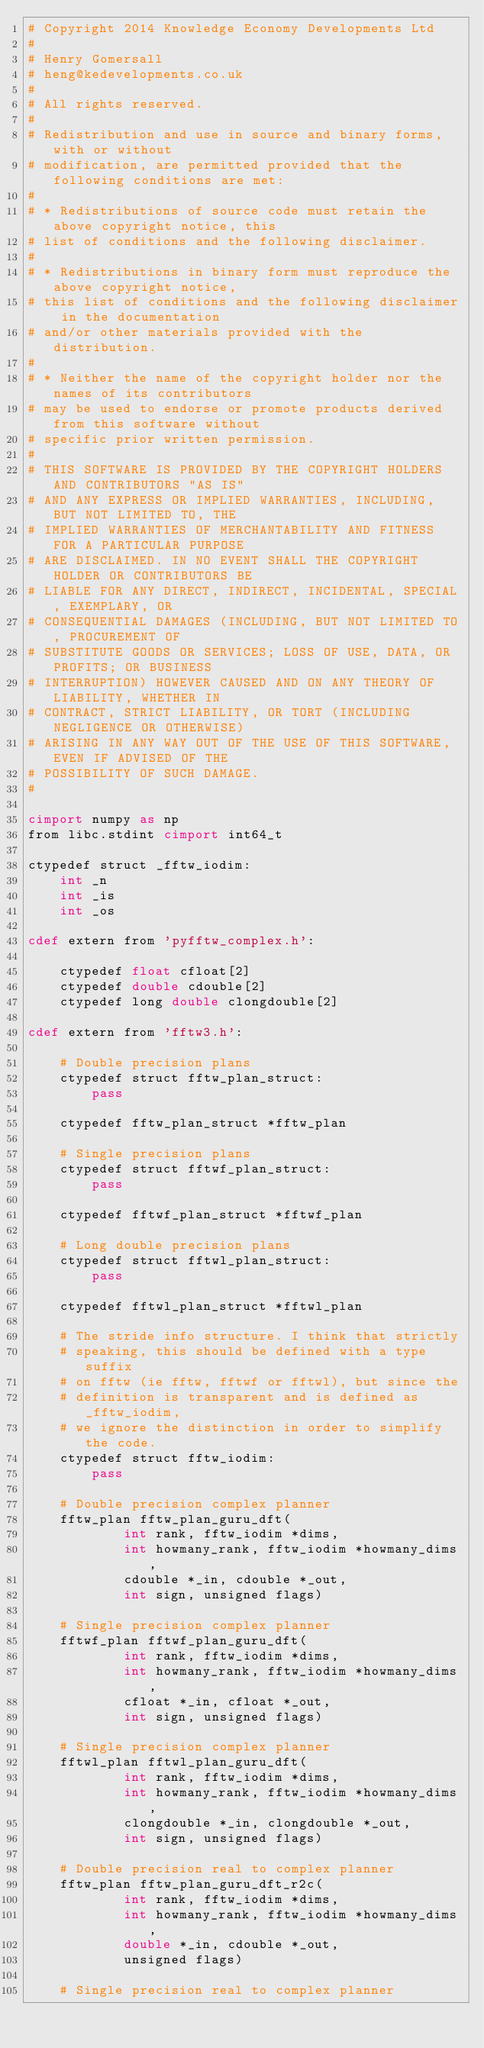Convert code to text. <code><loc_0><loc_0><loc_500><loc_500><_Cython_># Copyright 2014 Knowledge Economy Developments Ltd
# 
# Henry Gomersall
# heng@kedevelopments.co.uk
#
# All rights reserved.
#
# Redistribution and use in source and binary forms, with or without
# modification, are permitted provided that the following conditions are met:
#
# * Redistributions of source code must retain the above copyright notice, this
# list of conditions and the following disclaimer.
#
# * Redistributions in binary form must reproduce the above copyright notice,
# this list of conditions and the following disclaimer in the documentation
# and/or other materials provided with the distribution.
#
# * Neither the name of the copyright holder nor the names of its contributors
# may be used to endorse or promote products derived from this software without
# specific prior written permission.
#
# THIS SOFTWARE IS PROVIDED BY THE COPYRIGHT HOLDERS AND CONTRIBUTORS "AS IS"
# AND ANY EXPRESS OR IMPLIED WARRANTIES, INCLUDING, BUT NOT LIMITED TO, THE
# IMPLIED WARRANTIES OF MERCHANTABILITY AND FITNESS FOR A PARTICULAR PURPOSE
# ARE DISCLAIMED. IN NO EVENT SHALL THE COPYRIGHT HOLDER OR CONTRIBUTORS BE
# LIABLE FOR ANY DIRECT, INDIRECT, INCIDENTAL, SPECIAL, EXEMPLARY, OR
# CONSEQUENTIAL DAMAGES (INCLUDING, BUT NOT LIMITED TO, PROCUREMENT OF
# SUBSTITUTE GOODS OR SERVICES; LOSS OF USE, DATA, OR PROFITS; OR BUSINESS
# INTERRUPTION) HOWEVER CAUSED AND ON ANY THEORY OF LIABILITY, WHETHER IN
# CONTRACT, STRICT LIABILITY, OR TORT (INCLUDING NEGLIGENCE OR OTHERWISE)
# ARISING IN ANY WAY OUT OF THE USE OF THIS SOFTWARE, EVEN IF ADVISED OF THE
# POSSIBILITY OF SUCH DAMAGE.
#

cimport numpy as np
from libc.stdint cimport int64_t

ctypedef struct _fftw_iodim:
    int _n
    int _is
    int _os

cdef extern from 'pyfftw_complex.h':
    
    ctypedef float cfloat[2]
    ctypedef double cdouble[2]
    ctypedef long double clongdouble[2]

cdef extern from 'fftw3.h':
    
    # Double precision plans
    ctypedef struct fftw_plan_struct:
        pass

    ctypedef fftw_plan_struct *fftw_plan

    # Single precision plans
    ctypedef struct fftwf_plan_struct:
        pass

    ctypedef fftwf_plan_struct *fftwf_plan

    # Long double precision plans
    ctypedef struct fftwl_plan_struct:
        pass

    ctypedef fftwl_plan_struct *fftwl_plan

    # The stride info structure. I think that strictly
    # speaking, this should be defined with a type suffix
    # on fftw (ie fftw, fftwf or fftwl), but since the
    # definition is transparent and is defined as _fftw_iodim,
    # we ignore the distinction in order to simplify the code.
    ctypedef struct fftw_iodim:
        pass
    
    # Double precision complex planner
    fftw_plan fftw_plan_guru_dft(
            int rank, fftw_iodim *dims,
            int howmany_rank, fftw_iodim *howmany_dims,
            cdouble *_in, cdouble *_out,
            int sign, unsigned flags)
    
    # Single precision complex planner
    fftwf_plan fftwf_plan_guru_dft(
            int rank, fftw_iodim *dims,
            int howmany_rank, fftw_iodim *howmany_dims,
            cfloat *_in, cfloat *_out,
            int sign, unsigned flags)

    # Single precision complex planner
    fftwl_plan fftwl_plan_guru_dft(
            int rank, fftw_iodim *dims,
            int howmany_rank, fftw_iodim *howmany_dims,
            clongdouble *_in, clongdouble *_out,
            int sign, unsigned flags)
    
    # Double precision real to complex planner
    fftw_plan fftw_plan_guru_dft_r2c(
            int rank, fftw_iodim *dims,
            int howmany_rank, fftw_iodim *howmany_dims,
            double *_in, cdouble *_out,
            unsigned flags)
    
    # Single precision real to complex planner</code> 